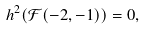<formula> <loc_0><loc_0><loc_500><loc_500>h ^ { 2 } ( \mathcal { F } ( - 2 , - 1 ) ) = 0 ,</formula> 